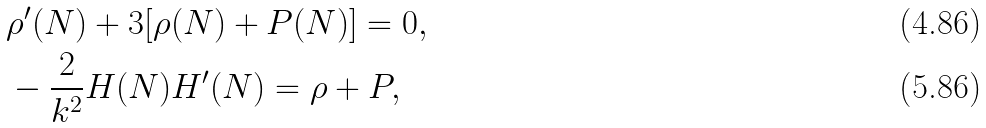Convert formula to latex. <formula><loc_0><loc_0><loc_500><loc_500>& \rho ^ { \prime } ( N ) + 3 [ \rho ( N ) + P ( N ) ] = 0 , \\ & - \frac { 2 } { k ^ { 2 } } H ( N ) H ^ { \prime } ( N ) = \rho + P ,</formula> 